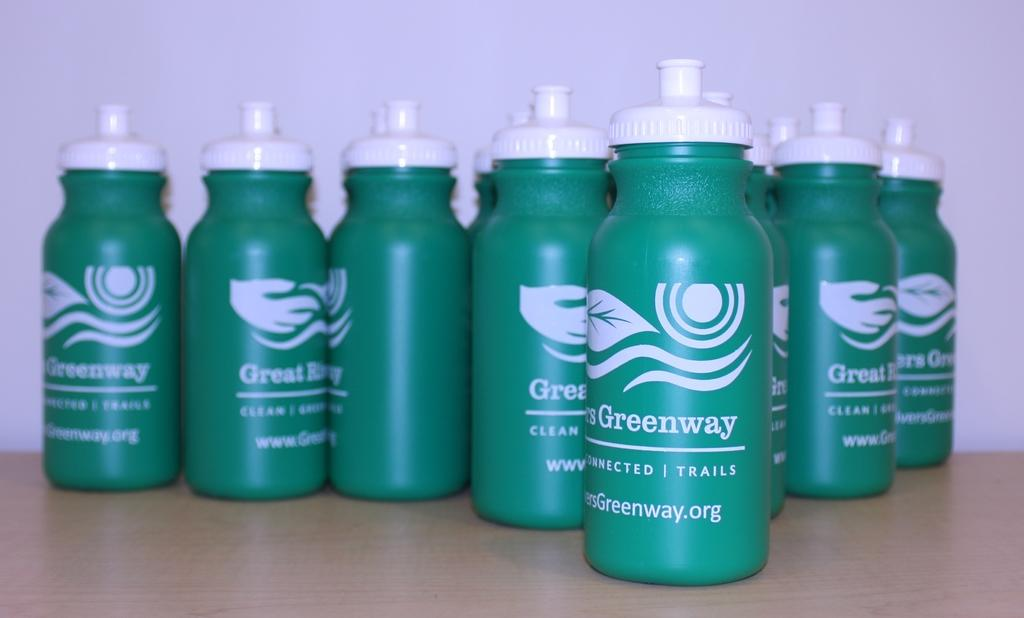<image>
Create a compact narrative representing the image presented. Green water bottle with the word Greenway on them sit on a surface. 